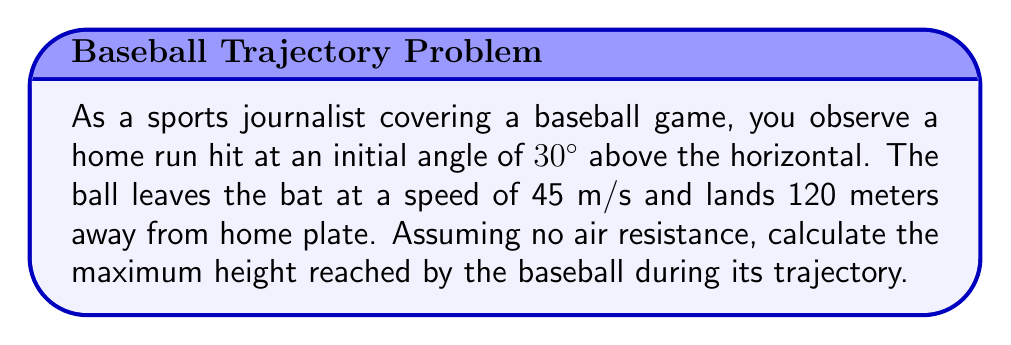What is the answer to this math problem? To solve this problem, we'll use the equations of projectile motion and trigonometry. Let's break it down step-by-step:

1) First, we need to find the time of flight. We can use the horizontal displacement equation:
   $$x = v_0 \cos \theta \cdot t$$
   Where $x = 120$ m, $v_0 = 45$ m/s, and $\theta = 30°$

2) Rearranging the equation:
   $$t = \frac{x}{v_0 \cos \theta} = \frac{120}{45 \cos 30°} = \frac{120}{45 \cdot \frac{\sqrt{3}}{2}} = 3.08 \text{ seconds}$$

3) Now that we have the time, we can find the maximum height using the vertical displacement equation:
   $$y = v_0 \sin \theta \cdot t - \frac{1}{2}gt^2$$
   Where $g = 9.8$ m/s²

4) The maximum height occurs at half the total time of flight, so we use $t = 1.54$ seconds:
   $$y_{max} = 45 \sin 30° \cdot 1.54 - \frac{1}{2} \cdot 9.8 \cdot 1.54^2$$

5) Simplifying:
   $$y_{max} = 45 \cdot 0.5 \cdot 1.54 - 4.9 \cdot 2.37$$
   $$y_{max} = 34.65 - 11.61 = 23.04 \text{ meters}$$

Therefore, the maximum height reached by the baseball is approximately 23.04 meters.
Answer: 23.04 meters 